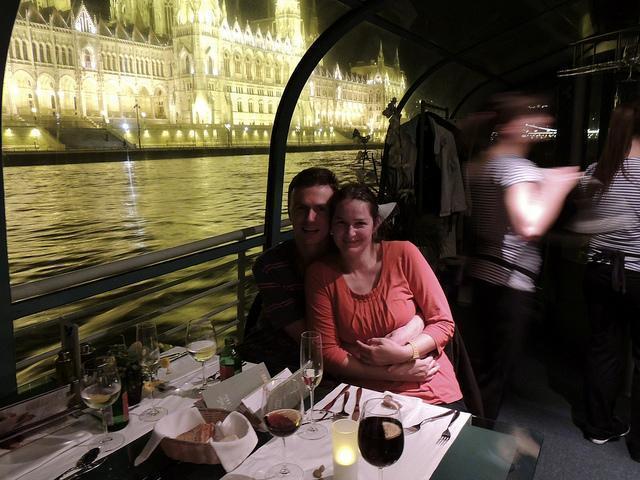Where is the couple most probably dining?
Select the accurate response from the four choices given to answer the question.
Options: Home, restaurant, park, boat. Boat. 